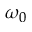<formula> <loc_0><loc_0><loc_500><loc_500>\omega _ { 0 }</formula> 